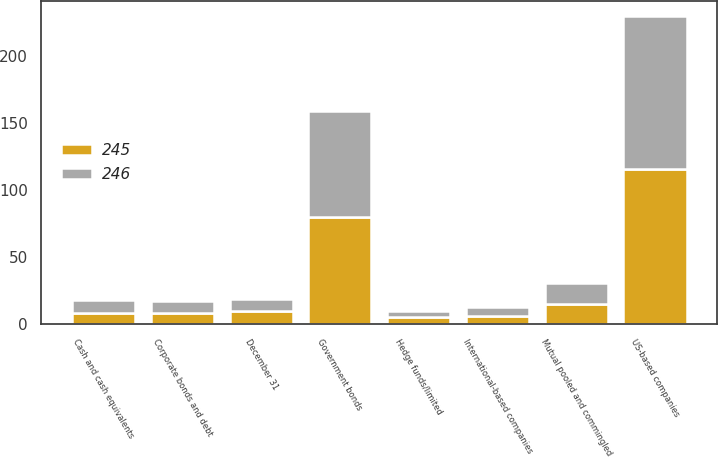Convert chart. <chart><loc_0><loc_0><loc_500><loc_500><stacked_bar_chart><ecel><fcel>December 31<fcel>Cash and cash equivalents<fcel>US-based companies<fcel>International-based companies<fcel>Government bonds<fcel>Corporate bonds and debt<fcel>Mutual pooled and commingled<fcel>Hedge funds/limited<nl><fcel>245<fcel>9.5<fcel>8<fcel>116<fcel>6<fcel>80<fcel>8<fcel>15<fcel>5<nl><fcel>246<fcel>9.5<fcel>10<fcel>114<fcel>7<fcel>79<fcel>9<fcel>16<fcel>5<nl></chart> 